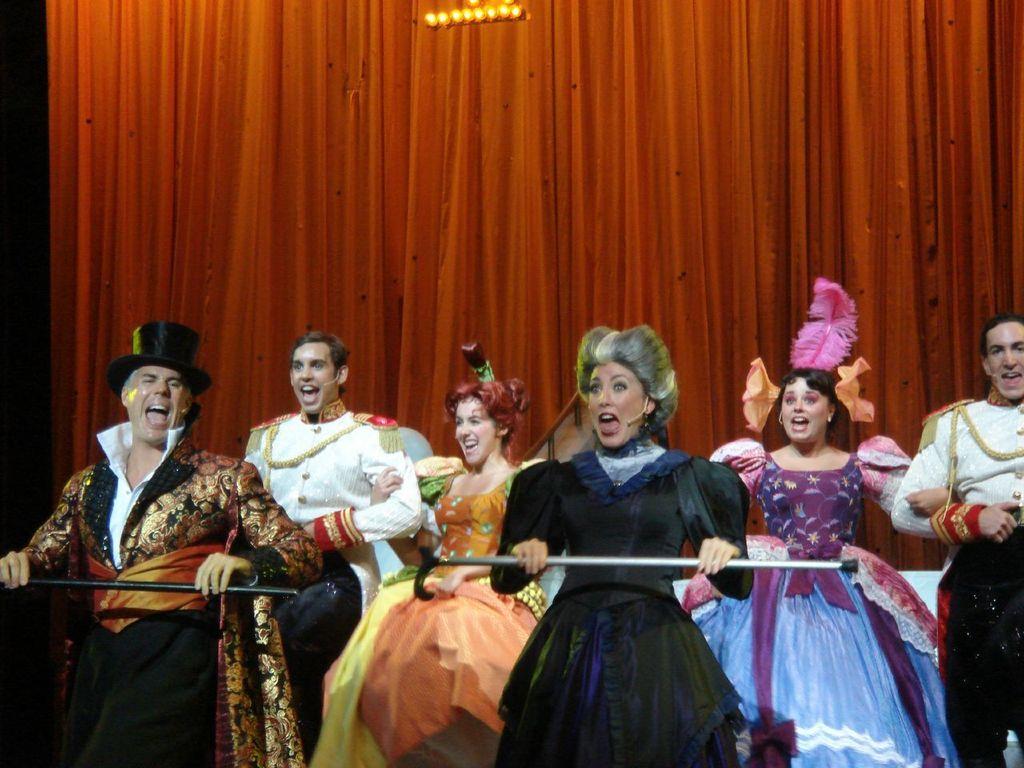In one or two sentences, can you explain what this image depicts? In this image there are group of persons dancing, there are persons holding an object, there is a person truncated towards the right of the image, there is a light truncated towards the top of the image, at the background of the image there is a curtain truncated. 